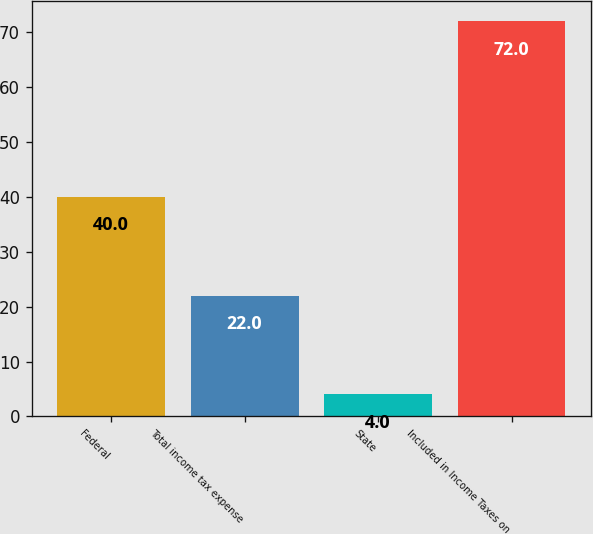<chart> <loc_0><loc_0><loc_500><loc_500><bar_chart><fcel>Federal<fcel>Total income tax expense<fcel>State<fcel>Included in Income Taxes on<nl><fcel>40<fcel>22<fcel>4<fcel>72<nl></chart> 